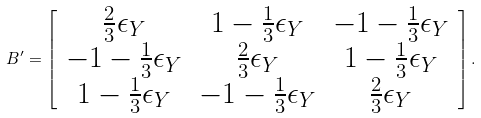<formula> <loc_0><loc_0><loc_500><loc_500>B ^ { \prime } = \left [ \begin{array} { c c c } \frac { 2 } { 3 } \epsilon _ { Y } & 1 - \frac { 1 } { 3 } \epsilon _ { Y } & - 1 - \frac { 1 } { 3 } \epsilon _ { Y } \\ - 1 - \frac { 1 } { 3 } \epsilon _ { Y } & \frac { 2 } { 3 } \epsilon _ { Y } & 1 - \frac { 1 } { 3 } \epsilon _ { Y } \\ 1 - \frac { 1 } { 3 } \epsilon _ { Y } & - 1 - \frac { 1 } { 3 } \epsilon _ { Y } & \frac { 2 } { 3 } \epsilon _ { Y } \\ \end{array} \right ] .</formula> 